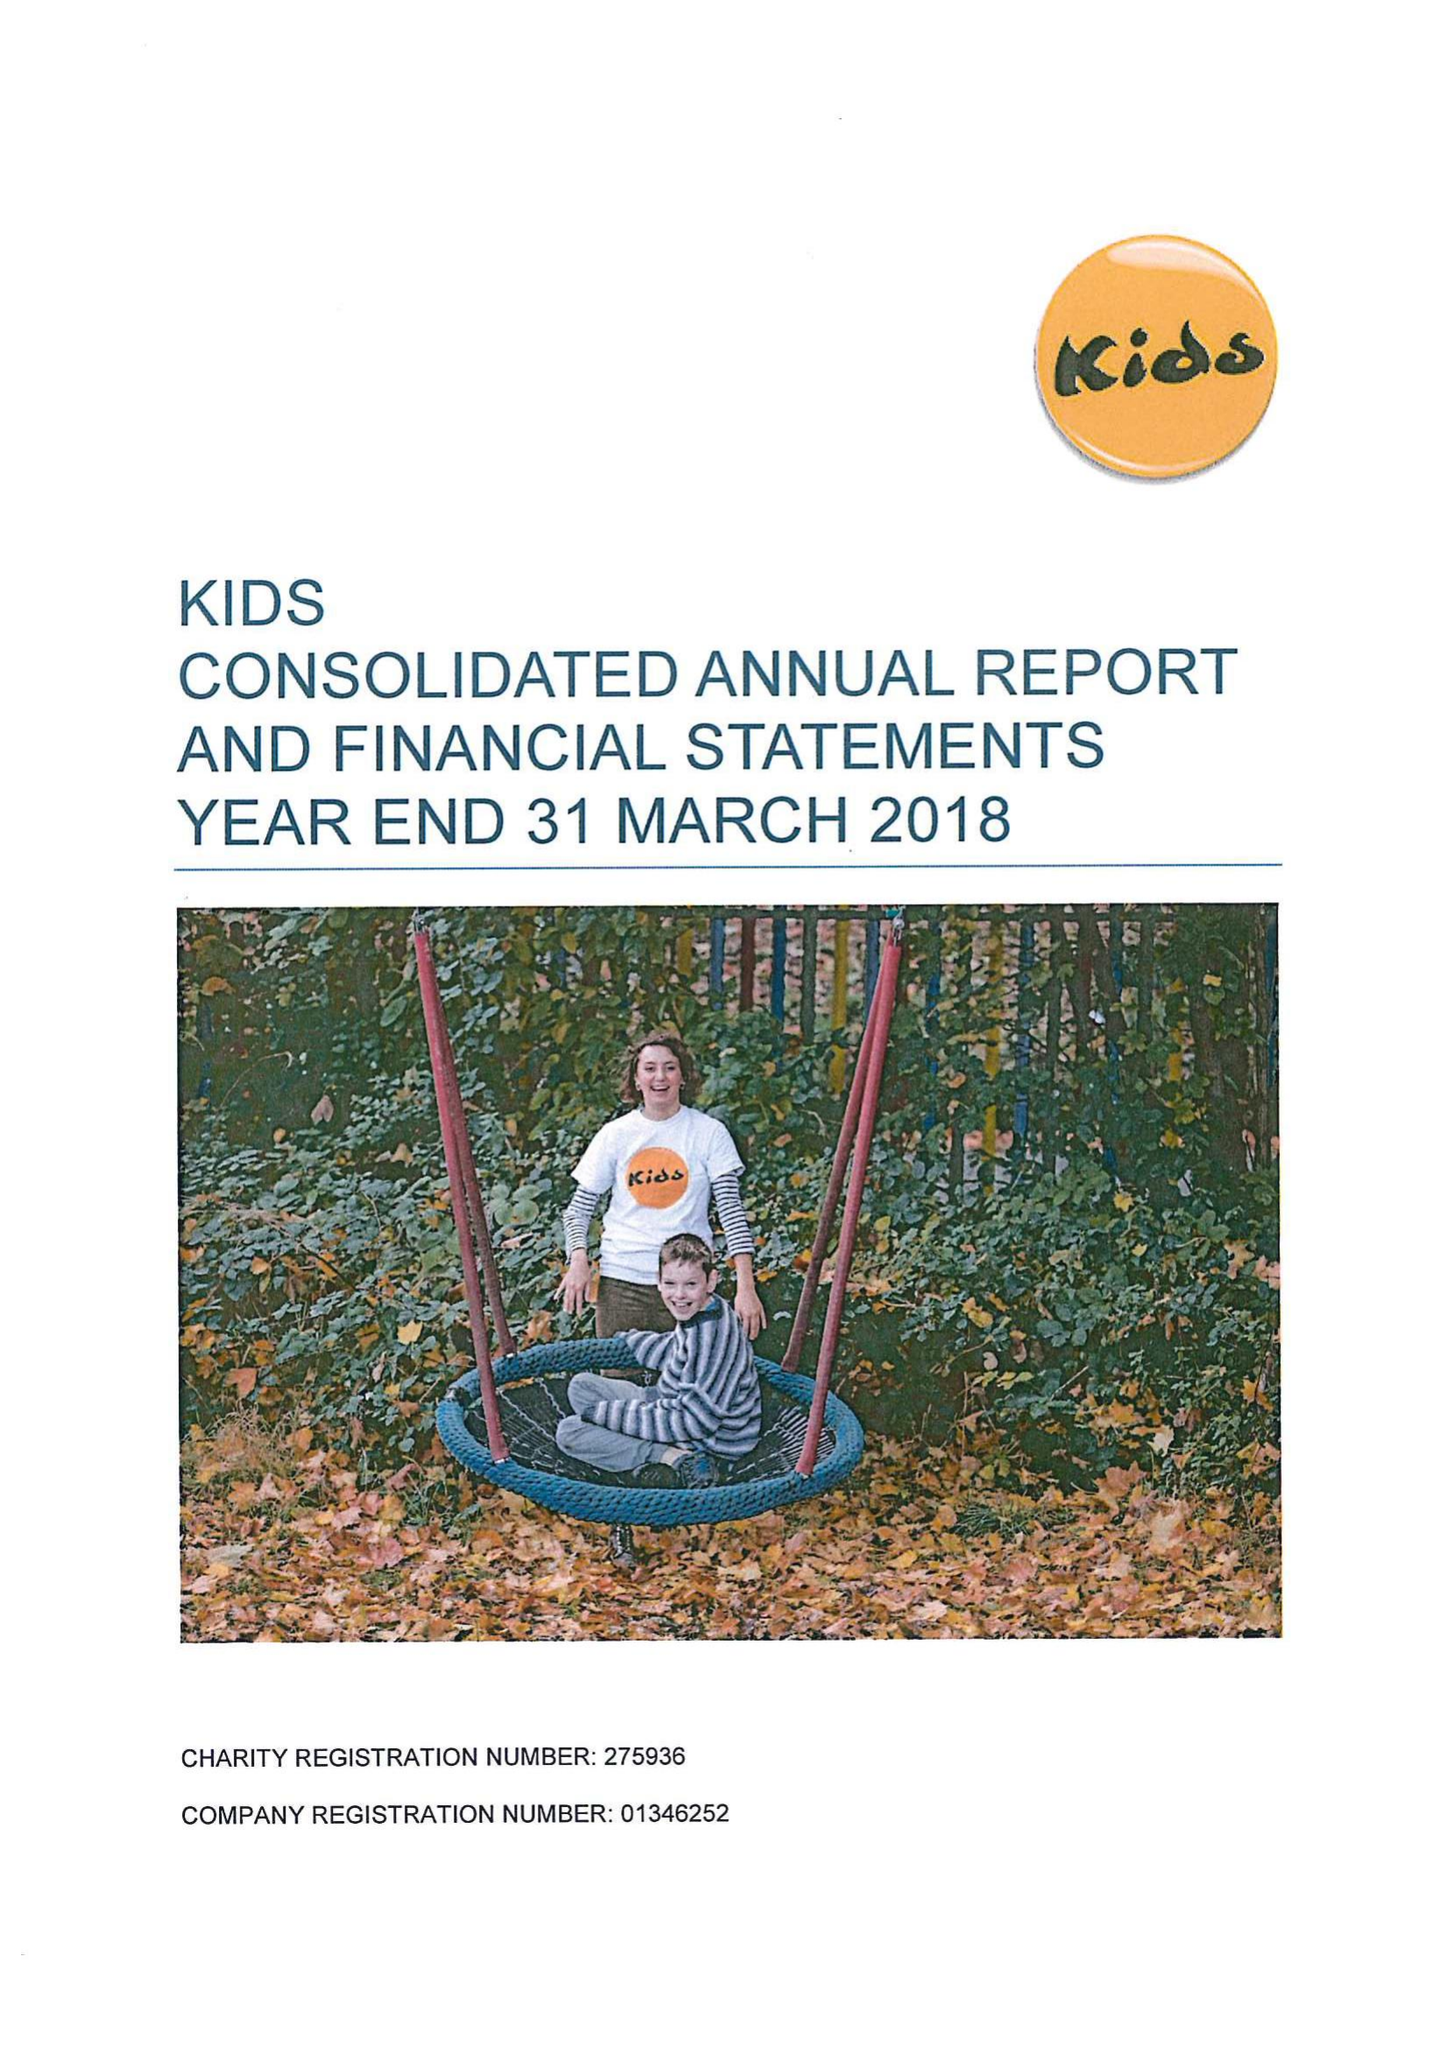What is the value for the charity_number?
Answer the question using a single word or phrase. 275936 